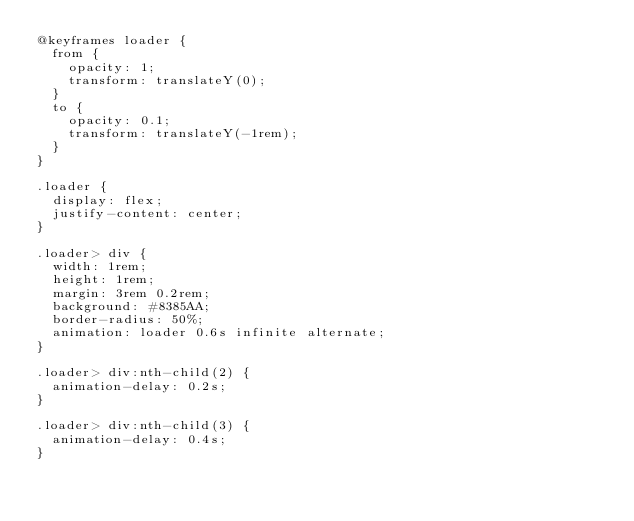<code> <loc_0><loc_0><loc_500><loc_500><_CSS_>@keyframes loader {
  from {
    opacity: 1;
    transform: translateY(0);
  }
  to {
    opacity: 0.1;
    transform: translateY(-1rem);
  }
}

.loader {
  display: flex;
  justify-content: center;
}

.loader> div {
  width: 1rem;
  height: 1rem;
  margin: 3rem 0.2rem;
  background: #8385AA;
  border-radius: 50%;
  animation: loader 0.6s infinite alternate;
}

.loader> div:nth-child(2) {
  animation-delay: 0.2s;
}

.loader> div:nth-child(3) {
  animation-delay: 0.4s;
}</code> 